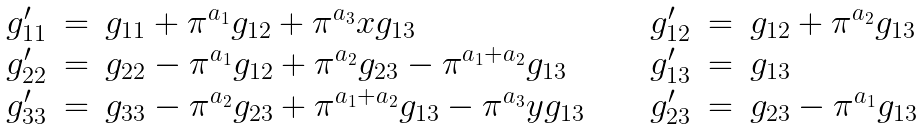<formula> <loc_0><loc_0><loc_500><loc_500>\begin{array} { r c l c r c l } g _ { 1 1 } ^ { \prime } & = & g _ { 1 1 } + \pi ^ { a _ { 1 } } g _ { 1 2 } + \pi ^ { a _ { 3 } } x g _ { 1 3 } & \quad & g _ { 1 2 } ^ { \prime } & = & g _ { 1 2 } + \pi ^ { a _ { 2 } } g _ { 1 3 } \\ g _ { 2 2 } ^ { \prime } & = & g _ { 2 2 } - \pi ^ { a _ { 1 } } g _ { 1 2 } + \pi ^ { a _ { 2 } } g _ { 2 3 } - \pi ^ { a _ { 1 } + a _ { 2 } } g _ { 1 3 } & & g _ { 1 3 } ^ { \prime } & = & g _ { 1 3 } \\ g _ { 3 3 } ^ { \prime } & = & g _ { 3 3 } - \pi ^ { a _ { 2 } } g _ { 2 3 } + \pi ^ { a _ { 1 } + a _ { 2 } } g _ { 1 3 } - \pi ^ { a _ { 3 } } y g _ { 1 3 } & & g _ { 2 3 } ^ { \prime } & = & g _ { 2 3 } - \pi ^ { a _ { 1 } } g _ { 1 3 } \end{array}</formula> 